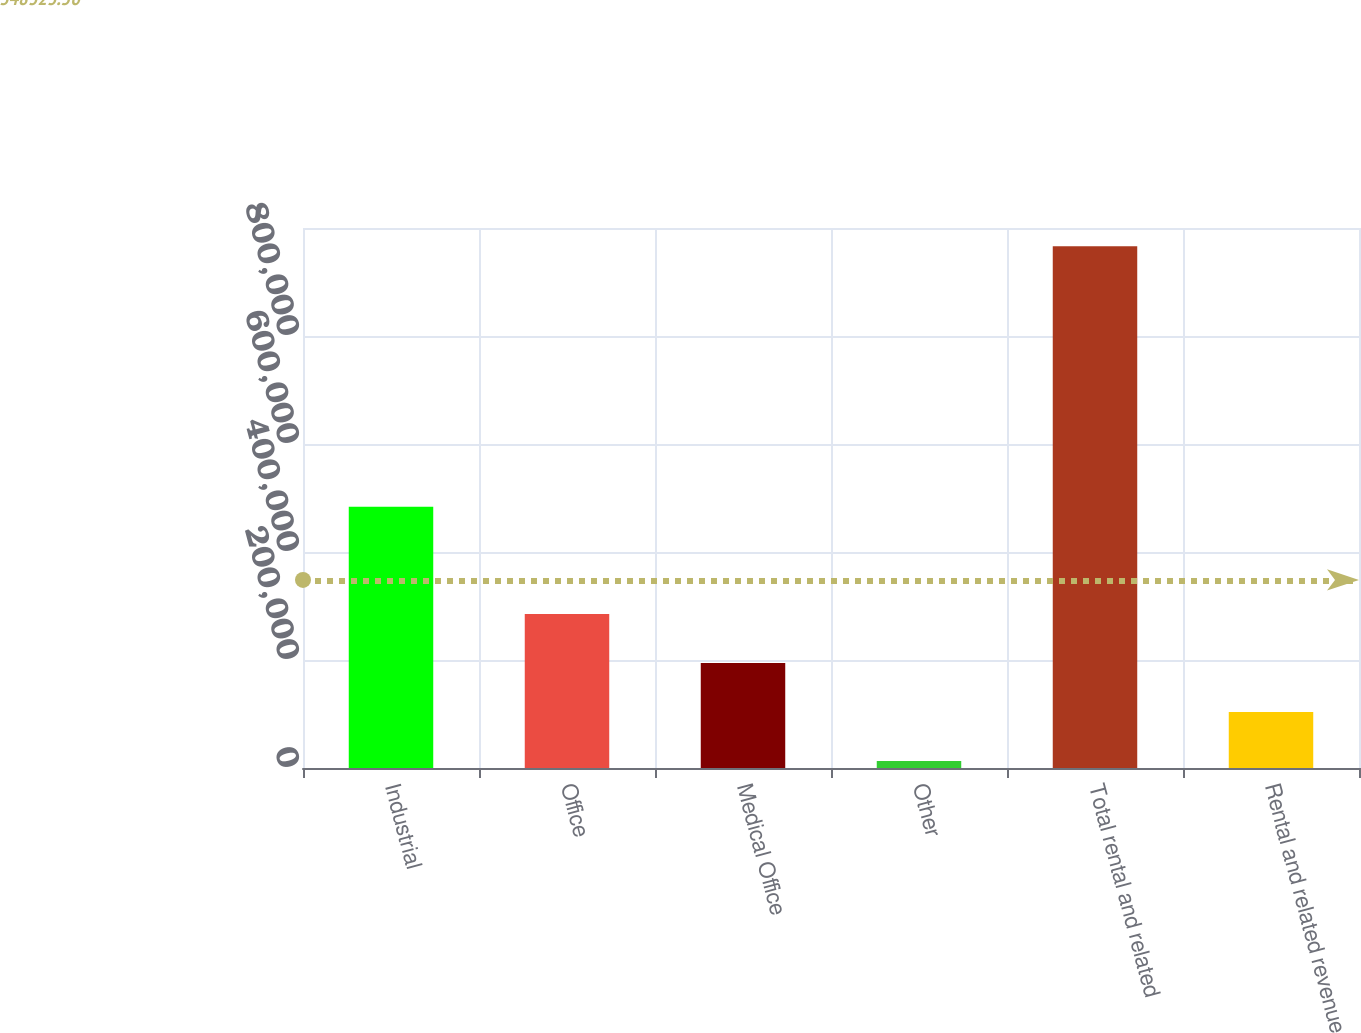Convert chart to OTSL. <chart><loc_0><loc_0><loc_500><loc_500><bar_chart><fcel>Industrial<fcel>Office<fcel>Medical Office<fcel>Other<fcel>Total rental and related<fcel>Rental and related revenue<nl><fcel>483679<fcel>285317<fcel>194468<fcel>12770<fcel>966043<fcel>103619<nl></chart> 